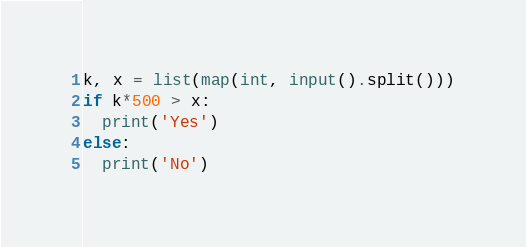Convert code to text. <code><loc_0><loc_0><loc_500><loc_500><_Python_>k, x = list(map(int, input().split()))
if k*500 > x:
  print('Yes')
else:
  print('No')</code> 